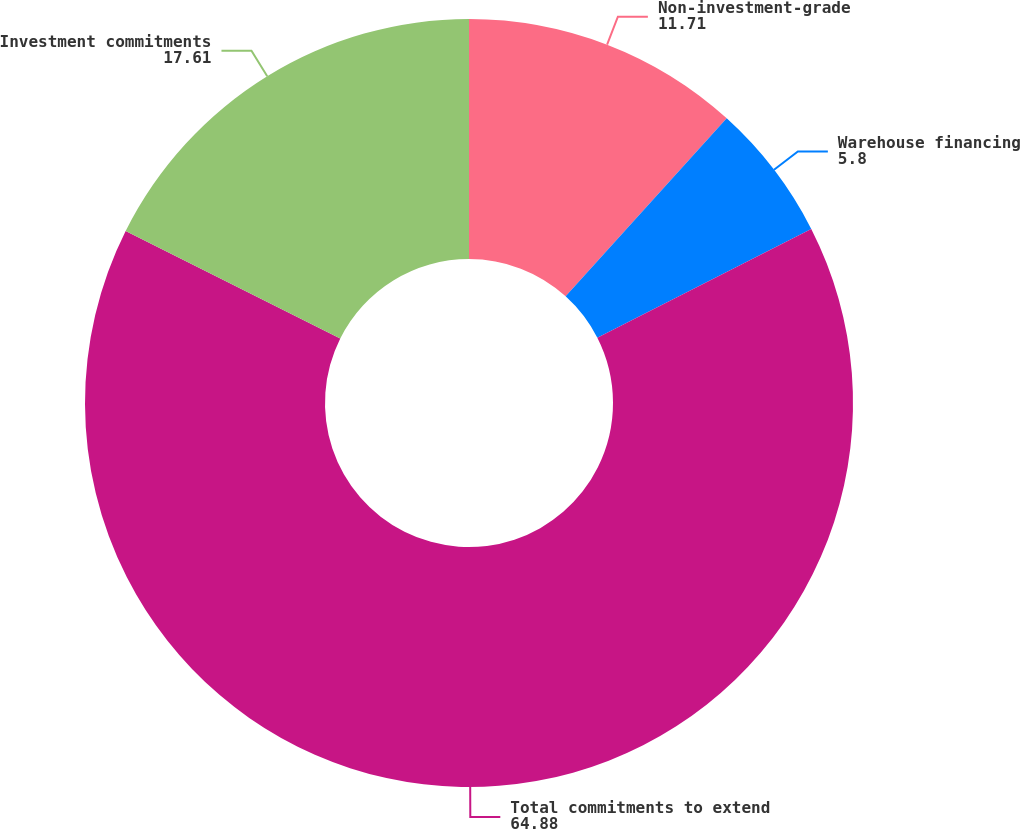Convert chart to OTSL. <chart><loc_0><loc_0><loc_500><loc_500><pie_chart><fcel>Non-investment-grade<fcel>Warehouse financing<fcel>Total commitments to extend<fcel>Investment commitments<nl><fcel>11.71%<fcel>5.8%<fcel>64.88%<fcel>17.61%<nl></chart> 